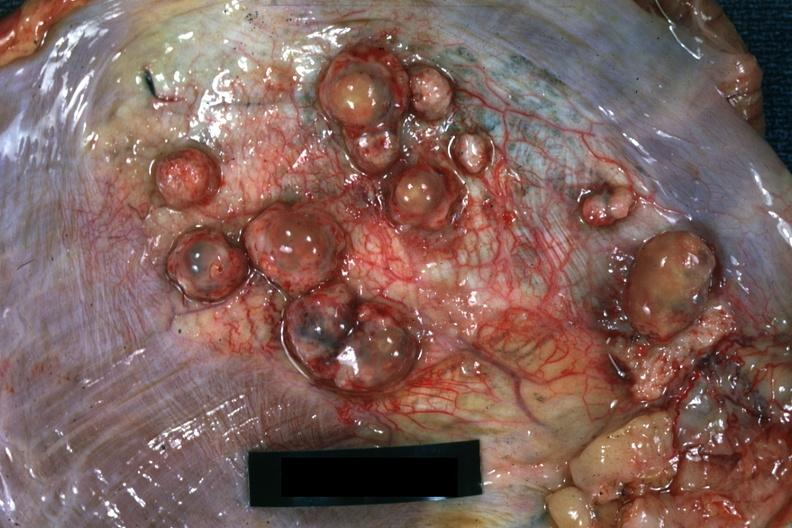what does this image show?
Answer the question using a single word or phrase. Close-up of tumor nodules in diaphragm 